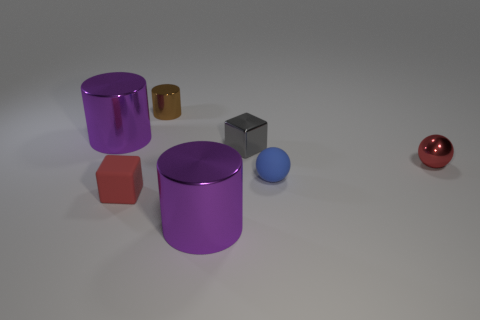Add 1 purple cylinders. How many objects exist? 8 Subtract all cylinders. How many objects are left? 4 Add 6 tiny gray things. How many tiny gray things exist? 7 Subtract 0 red cylinders. How many objects are left? 7 Subtract all rubber spheres. Subtract all spheres. How many objects are left? 4 Add 1 tiny rubber spheres. How many tiny rubber spheres are left? 2 